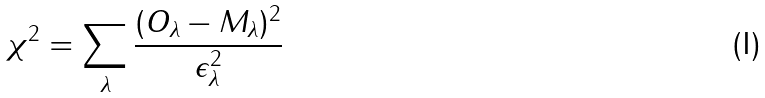<formula> <loc_0><loc_0><loc_500><loc_500>\chi ^ { 2 } = \sum _ { \lambda } \frac { ( O _ { \lambda } - M _ { \lambda } ) ^ { 2 } } { \epsilon _ { \lambda } ^ { 2 } }</formula> 